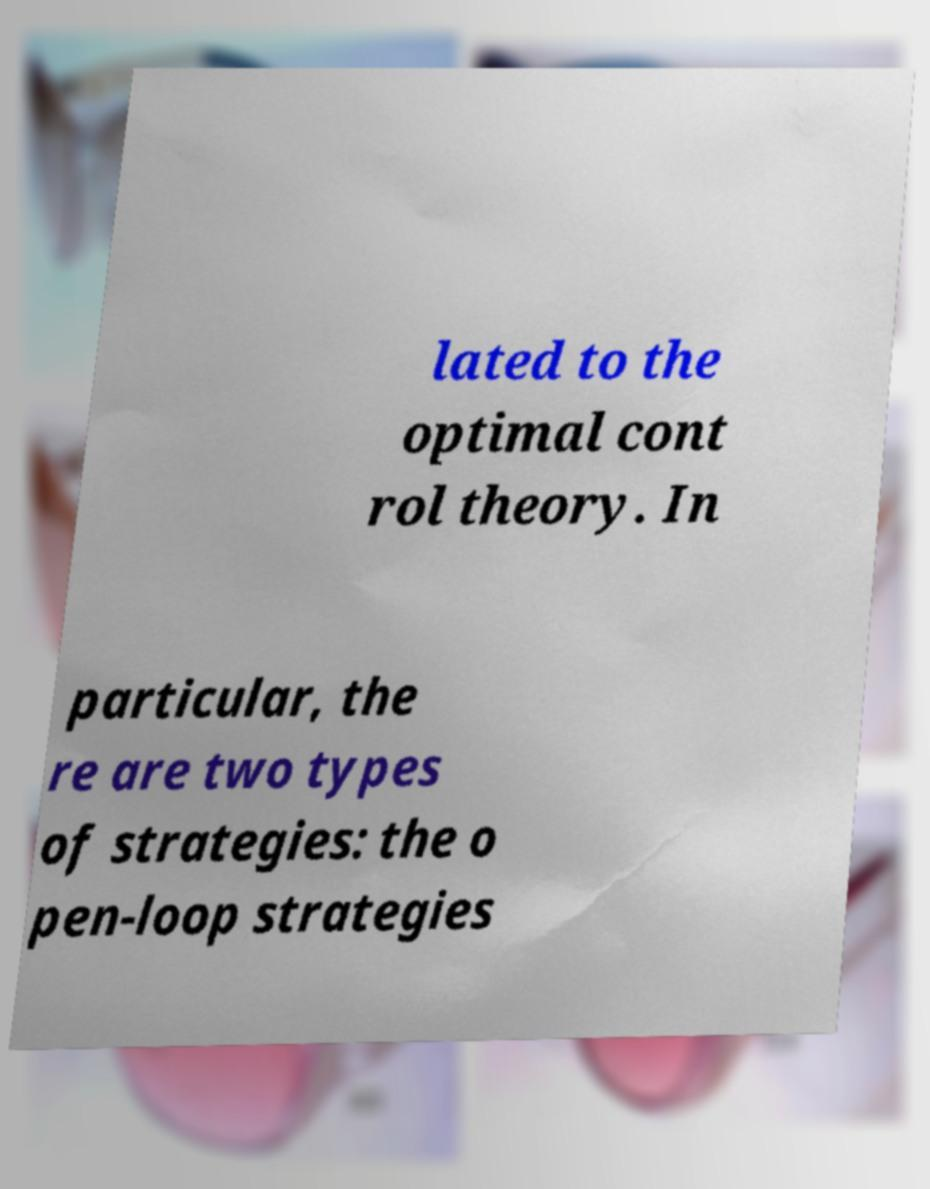For documentation purposes, I need the text within this image transcribed. Could you provide that? lated to the optimal cont rol theory. In particular, the re are two types of strategies: the o pen-loop strategies 